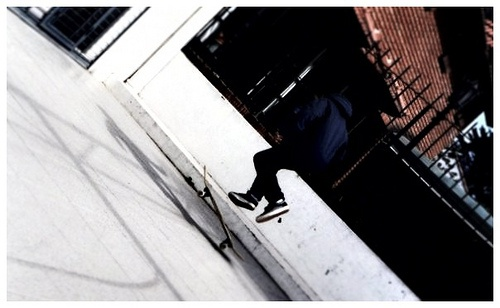Describe the objects in this image and their specific colors. I can see people in white, black, lightgray, gray, and navy tones and skateboard in white, black, gray, darkgray, and lightgray tones in this image. 